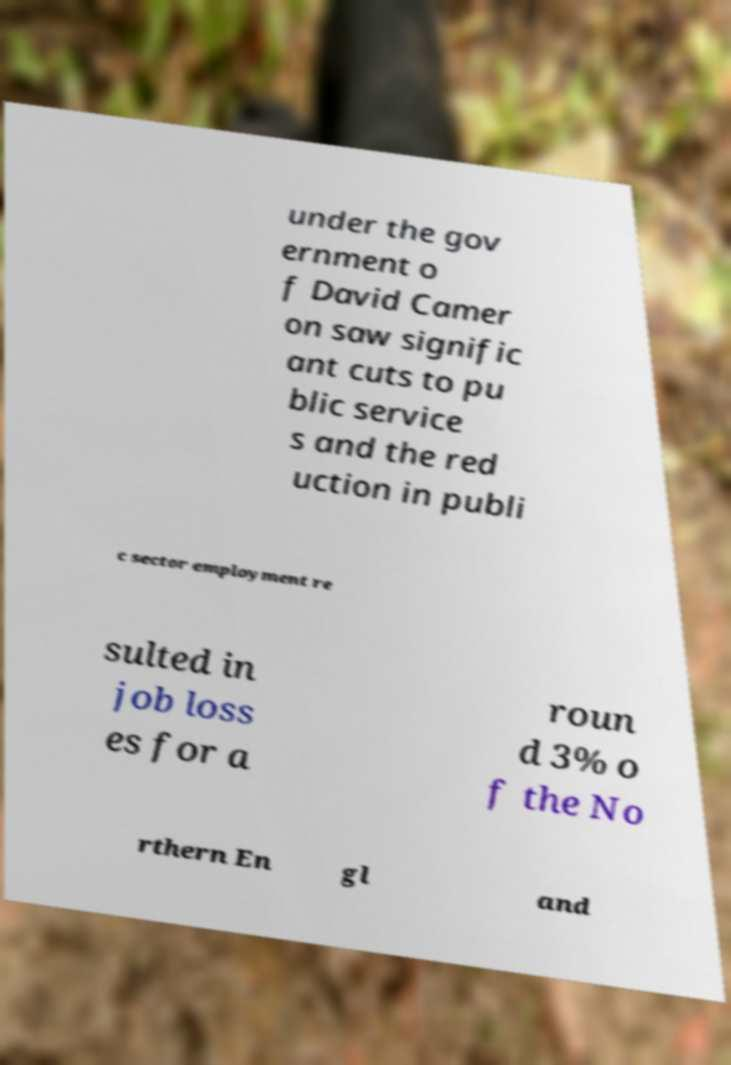I need the written content from this picture converted into text. Can you do that? under the gov ernment o f David Camer on saw signific ant cuts to pu blic service s and the red uction in publi c sector employment re sulted in job loss es for a roun d 3% o f the No rthern En gl and 